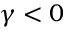Convert formula to latex. <formula><loc_0><loc_0><loc_500><loc_500>\gamma < 0</formula> 